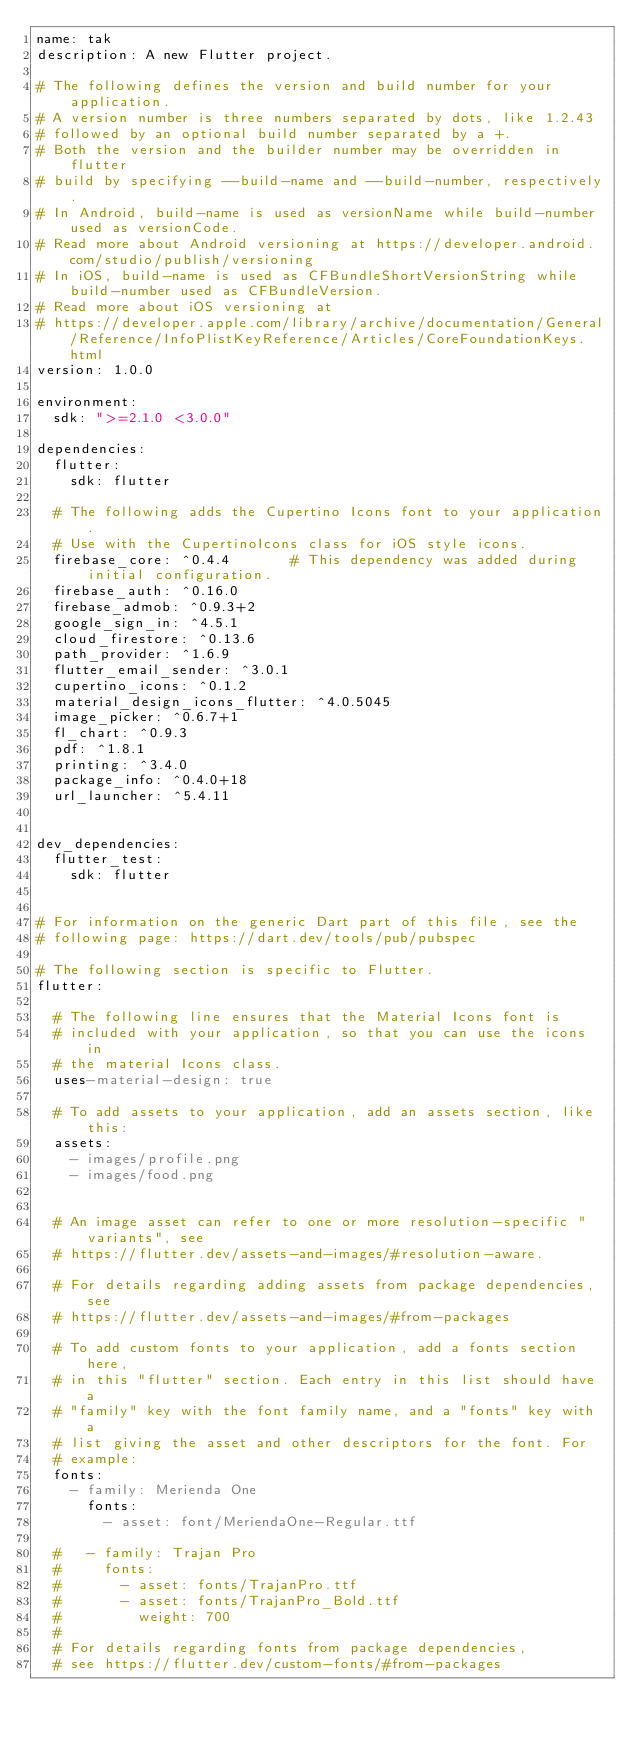Convert code to text. <code><loc_0><loc_0><loc_500><loc_500><_YAML_>name: tak
description: A new Flutter project.

# The following defines the version and build number for your application.
# A version number is three numbers separated by dots, like 1.2.43
# followed by an optional build number separated by a +.
# Both the version and the builder number may be overridden in flutter
# build by specifying --build-name and --build-number, respectively.
# In Android, build-name is used as versionName while build-number used as versionCode.
# Read more about Android versioning at https://developer.android.com/studio/publish/versioning
# In iOS, build-name is used as CFBundleShortVersionString while build-number used as CFBundleVersion.
# Read more about iOS versioning at
# https://developer.apple.com/library/archive/documentation/General/Reference/InfoPlistKeyReference/Articles/CoreFoundationKeys.html
version: 1.0.0

environment:
  sdk: ">=2.1.0 <3.0.0"

dependencies:
  flutter:
    sdk: flutter

  # The following adds the Cupertino Icons font to your application.
  # Use with the CupertinoIcons class for iOS style icons.
  firebase_core: ^0.4.4       # This dependency was added during initial configuration.
  firebase_auth: ^0.16.0
  firebase_admob: ^0.9.3+2
  google_sign_in: ^4.5.1
  cloud_firestore: ^0.13.6
  path_provider: ^1.6.9
  flutter_email_sender: ^3.0.1
  cupertino_icons: ^0.1.2
  material_design_icons_flutter: ^4.0.5045
  image_picker: ^0.6.7+1
  fl_chart: ^0.9.3
  pdf: ^1.8.1
  printing: ^3.4.0
  package_info: ^0.4.0+18
  url_launcher: ^5.4.11
  

dev_dependencies:
  flutter_test:
    sdk: flutter


# For information on the generic Dart part of this file, see the
# following page: https://dart.dev/tools/pub/pubspec

# The following section is specific to Flutter.
flutter:

  # The following line ensures that the Material Icons font is
  # included with your application, so that you can use the icons in
  # the material Icons class.
  uses-material-design: true

  # To add assets to your application, add an assets section, like this:
  assets:
    - images/profile.png
    - images/food.png


  # An image asset can refer to one or more resolution-specific "variants", see
  # https://flutter.dev/assets-and-images/#resolution-aware.

  # For details regarding adding assets from package dependencies, see
  # https://flutter.dev/assets-and-images/#from-packages

  # To add custom fonts to your application, add a fonts section here,
  # in this "flutter" section. Each entry in this list should have a
  # "family" key with the font family name, and a "fonts" key with a
  # list giving the asset and other descriptors for the font. For
  # example:
  fonts:
    - family: Merienda One
      fonts:
        - asset: font/MeriendaOne-Regular.ttf

  #   - family: Trajan Pro
  #     fonts:
  #       - asset: fonts/TrajanPro.ttf
  #       - asset: fonts/TrajanPro_Bold.ttf
  #         weight: 700
  #
  # For details regarding fonts from package dependencies,
  # see https://flutter.dev/custom-fonts/#from-packages
</code> 